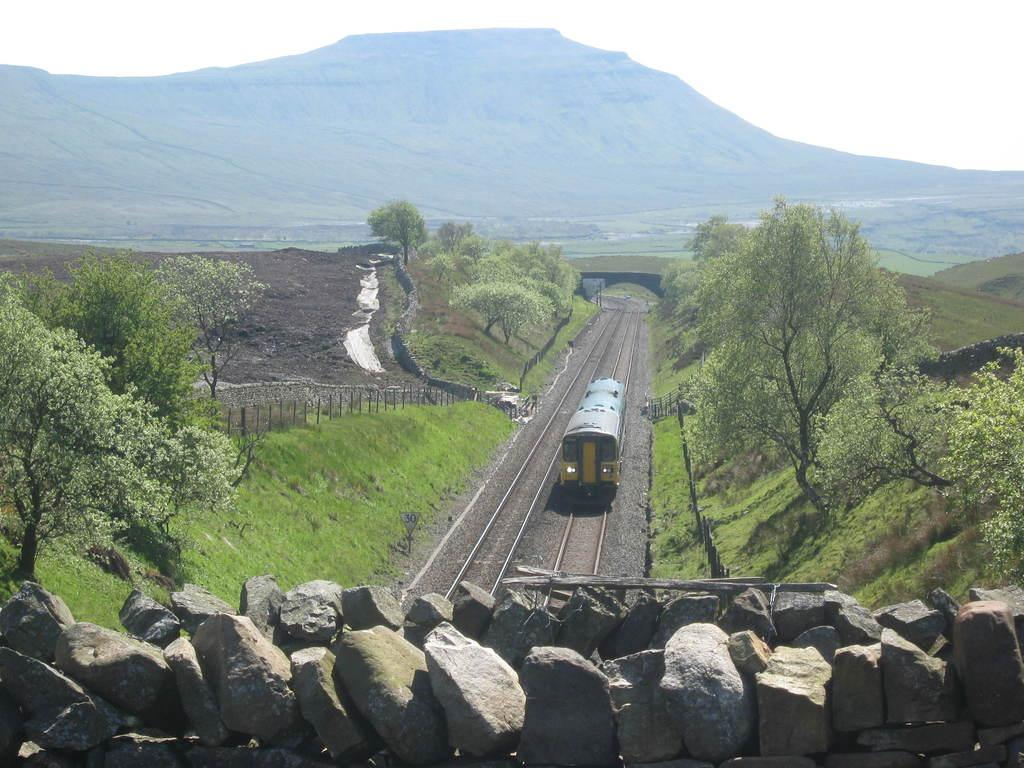What is the main subject in the center of the image? There is a train on the track in the center of the image. What structure can be seen in the image? There is a bridge in the image. What is present at the bottom of the image? There are stones at the bottom of the image. What type of vegetation is visible in the background of the image? There are trees in the background of the image. What architectural feature is present in the background of the image? There is a fence in the background of the image. What geographical feature is visible in the background of the image? There are hills in the background of the image. What is visible in the sky in the background of the image? The sky is visible in the background of the image. How many deer can be seen in the image? There are no deer present in the image. What type of camera is being used to take the picture? There is no information about a camera being used to take the picture, as we are looking at the image directly. 